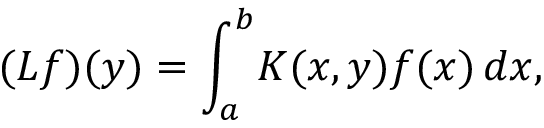<formula> <loc_0><loc_0><loc_500><loc_500>( L f ) ( y ) = \int _ { a } ^ { b } \, K ( x , y ) f ( x ) \, d x ,</formula> 